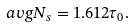Convert formula to latex. <formula><loc_0><loc_0><loc_500><loc_500>\ a v g { N _ { s } } = 1 . 6 1 2 \tau _ { 0 } .</formula> 